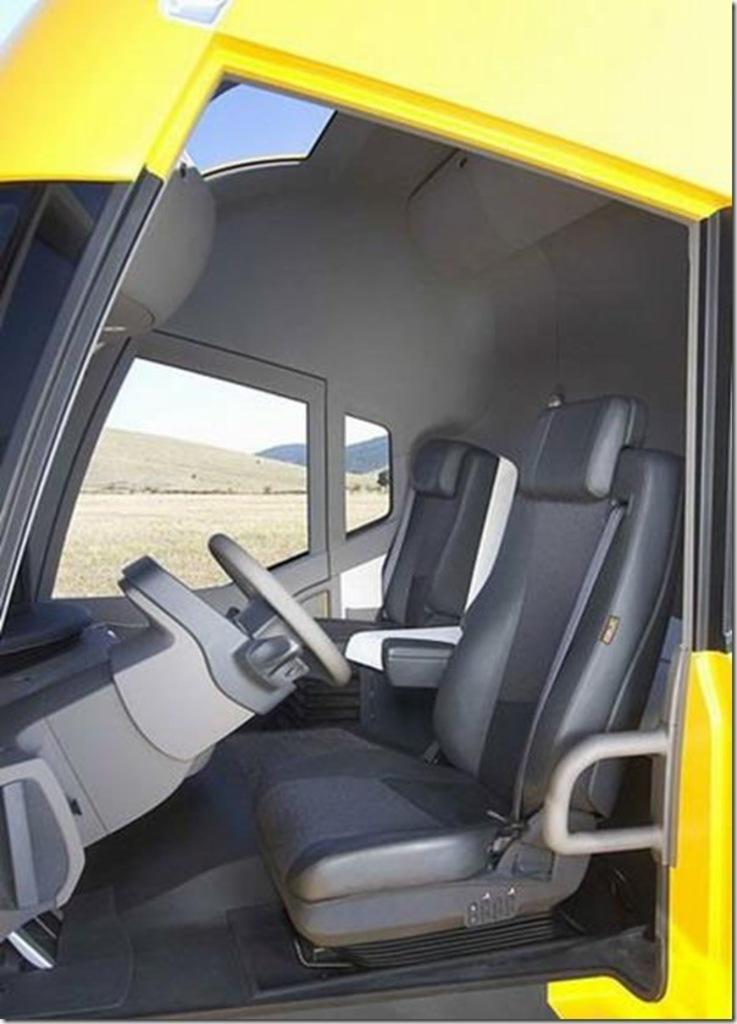Can you describe this image briefly? In this image we can see the inside view of a vehicle and from the glass window of the vehicle we can see hills, ground and also sky. 